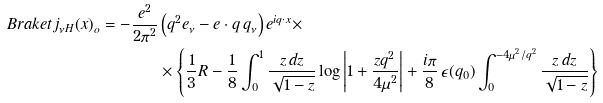<formula> <loc_0><loc_0><loc_500><loc_500>\ B r a k e t { j _ { \nu H } ( x ) } _ { o } = - \frac { e ^ { 2 } } { 2 \pi ^ { 2 } } & \left ( q ^ { 2 } e _ { \nu } - e \cdot q \, q _ { \nu } \right ) e ^ { i q \cdot x } \times \\ & \times \left \{ \frac { 1 } { 3 } R - \frac { 1 } { 8 } \int _ { 0 } ^ { 1 } \frac { z \, d z } { \sqrt { 1 - z } } \log \left | 1 + \frac { z q ^ { 2 } } { 4 \mu ^ { 2 } } \right | + \frac { i \pi } { 8 } \, \epsilon ( q _ { 0 } ) \int _ { 0 } ^ { - 4 \mu ^ { 2 } / q ^ { 2 } } \frac { z \, d z } { \sqrt { 1 - z } } \right \}</formula> 